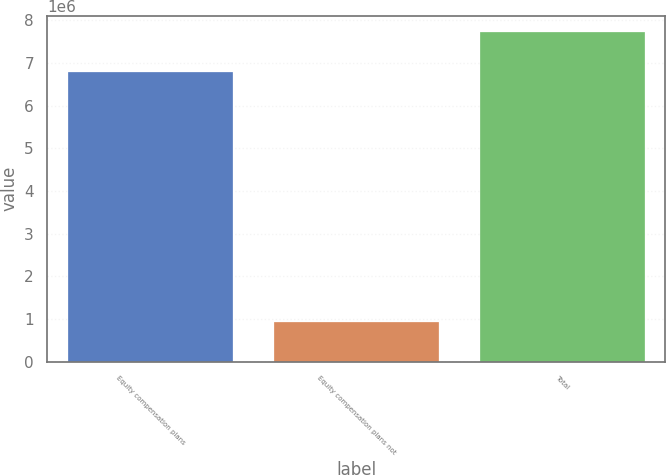<chart> <loc_0><loc_0><loc_500><loc_500><bar_chart><fcel>Equity compensation plans<fcel>Equity compensation plans not<fcel>Total<nl><fcel>6.79388e+06<fcel>927113<fcel>7.72099e+06<nl></chart> 